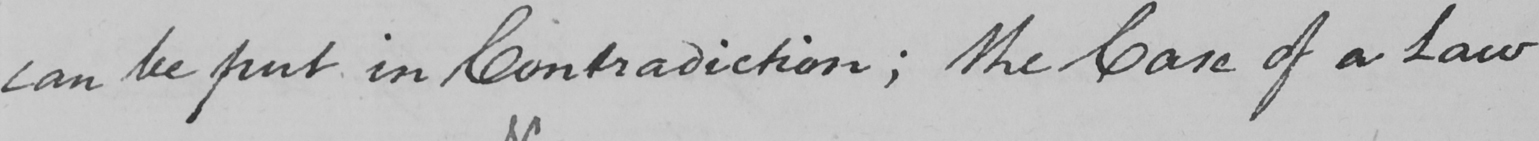Please transcribe the handwritten text in this image. can be put in Contradiction ; the Case of a Law 